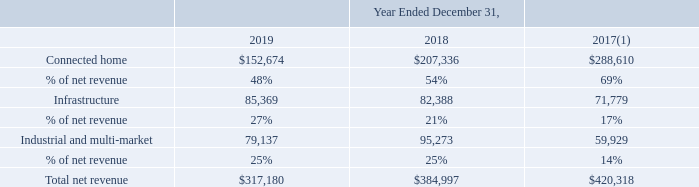Revenue by Market The table below presents disaggregated net revenues by market (in thousands):
(1) Due to the adoption of ASC 606 on January 1, 2018 using the modified retrospective method, amounts prior to 2018 have not been adjusted to reflect the change to recognize certain distributor sales upon sale to the distributor, or the sell-in method, from recognition upon the Company's sale to the distributors' end customers, or the sellthrough method, which required the deferral of revenue and profit on such distributor sales.
Revenues from sales to the Company’s distributors accounted for 52%, 42% and 34% of net revenue for the years ended December 31, 2019, 2018 and 2017, respectively.
After using the modified retrospective method, amounts prior to which year have not been adjusted? 2018. What was the revenue from sales to the Company's distributors from 2019, 2018 and 2017 respectively? 52%, 42%, 34%. What was the Connected home revenue in 2019?
Answer scale should be: thousand. $152,674. What was the change in Connected home from 2018 to 2019?
Answer scale should be: thousand. 152,674 - 207,336
Answer: -54662. What was the average Infrastructure between 2017-2019?
Answer scale should be: thousand. (85,369 + 82,388 + 71,779) / 3
Answer: 79845.33. In which year was Total net revenue less than 400,000 thousands? Locate and analyze total net revenue in row 9
answer: 2019, 2018. 